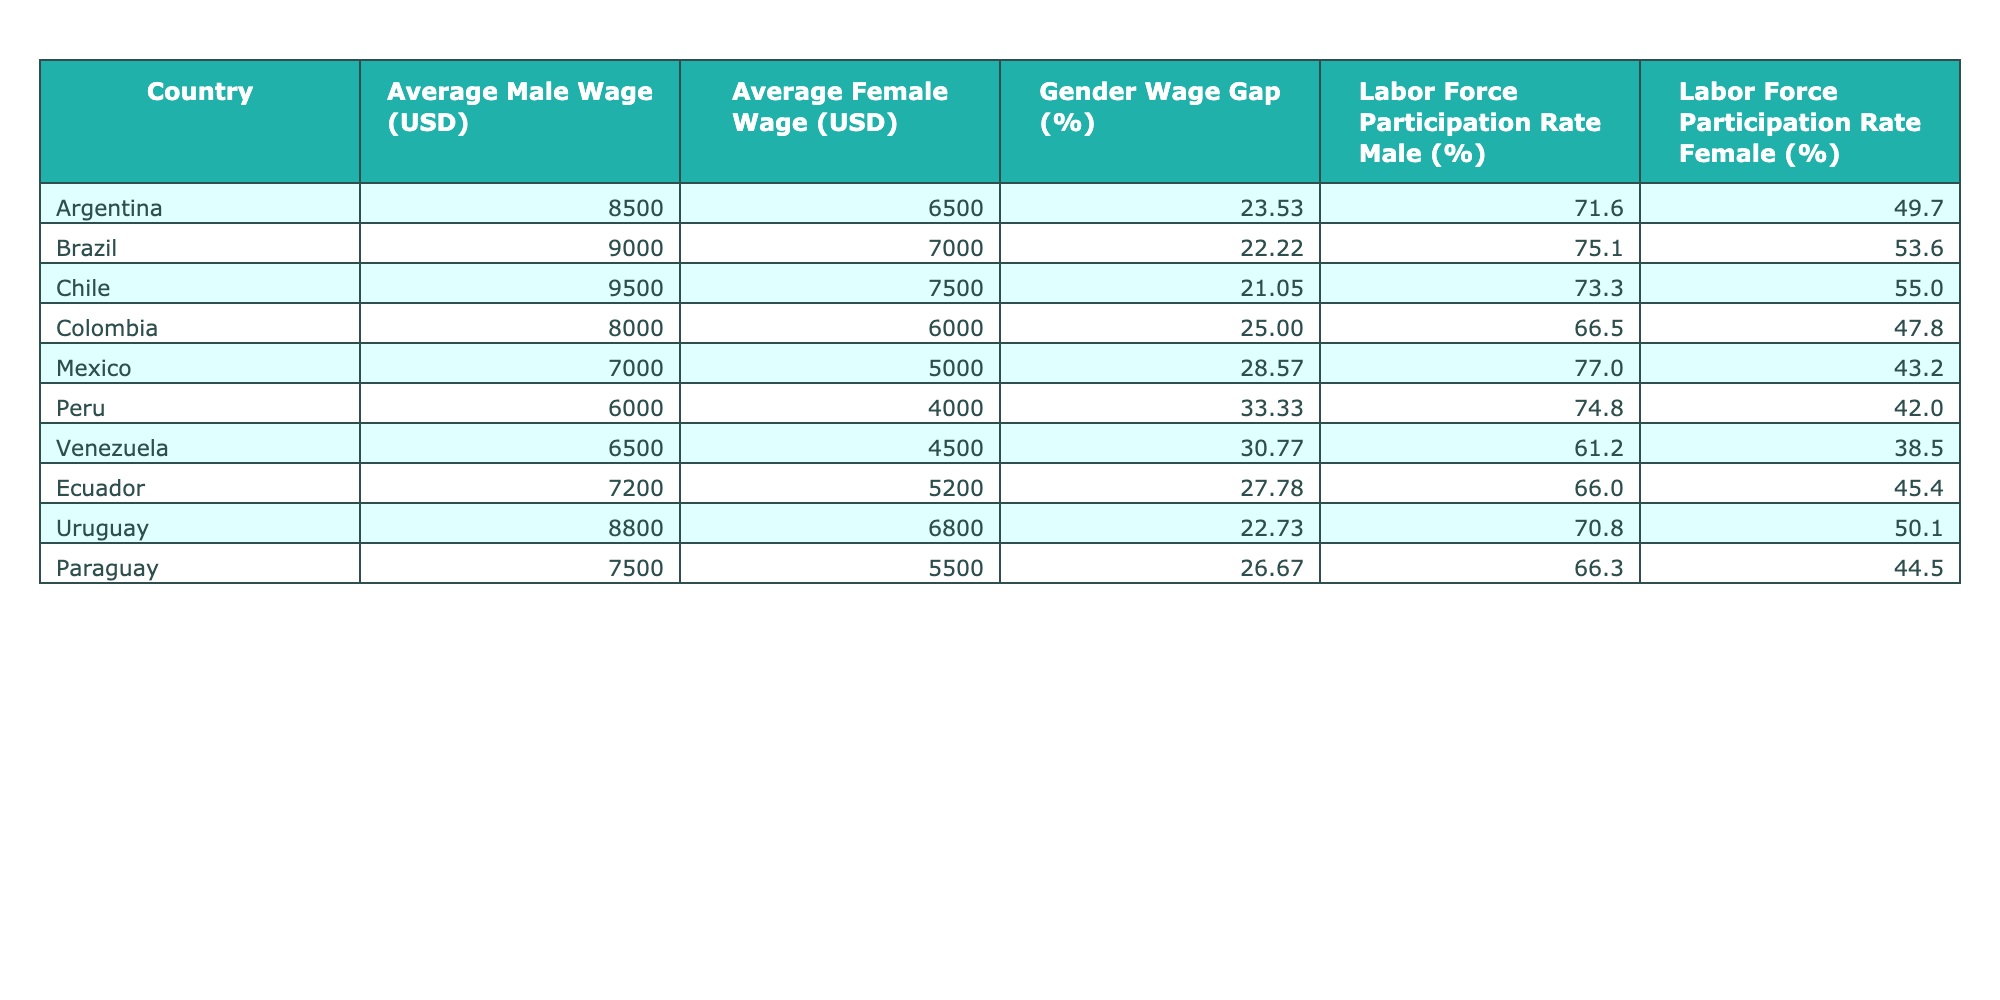What is the average male wage in Brazil? From the table, the specific value for the average male wage in Brazil is listed as 9000 USD.
Answer: 9000 USD Which country has the highest gender wage gap? By examining the table, the gender wage gap for Peru is 33.33%, which is the highest among the listed countries.
Answer: Peru What is the average female wage across all countries? The average female wage can be calculated by summing all the female wages (6500 + 7000 + 7500 + 6000 + 5000 + 4000 + 4500 + 5200 + 6800 + 5500) = 58800 USD and dividing by the number of countries (10), resulting in an average of 5880 USD.
Answer: 5880 USD Is the labor force participation rate for females in Argentina higher than that in Venezuela? The labor force participation rate for females in Argentina is 49.7%, and for Venezuela, it is 38.5%. Since 49.7% is greater than 38.5%, the statement is true.
Answer: Yes How much lower is the average male wage in Peru compared to the average female wage in Argentina? The average male wage in Peru is 6000 USD and the average female wage in Argentina is 6500 USD. The difference is 6500 - 6000 = 500 USD, indicating that the average male wage in Peru is 500 USD lower than the average female wage in Argentina.
Answer: 500 USD Which country has the closest average wages between genders? By reviewing the gender wage gaps, the smallest difference is in Chile with a gender wage gap of 21.05%, indicating that wages for males and females are closest in this country.
Answer: Chile What is the percentage difference in labor force participation rate between males and females in Colombia? In Colombia, males have a labor force participation rate of 66.5% and females have 47.8%. The percentage difference is calculated as (66.5 - 47.8) / 66.5 * 100 = 28.06%, showing the disparity in participation rates.
Answer: 28.06% Does any country have a gender wage gap of less than 22%? By checking the table, the countries with gender wage gaps are Argentine (23.53%), Brazil (22.22%), Chile (21.05%), and others. Since Chile has a gap of 21.05%, it's true that there is at least one country with a gender wage gap of less than 22%.
Answer: Yes What are the average male and female wages in Uruguay and how do they compare to each other? In Uruguay, the average male wage is 8800 USD and the average female wage is 6800 USD. The difference is 8800 - 6800 = 2000 USD, indicating that the male wage is 2000 USD higher than the female wage in Uruguay.
Answer: 2000 USD Which two countries have the highest average male and female wages, respectively? The highest average male wage is in Chile at 9500 USD, and the highest average female wage is also in Chile at 7500 USD. Thus, Chile holds the top position for both categories.
Answer: Chile How does the labor force participation rate for females in Peru compare to the overall average in the table? The average labor force participation rate for females across all the listed countries is (49.7 + 53.6 + 55.0 + 47.8 + 43.2 + 42.0 + 38.5 + 45.4 + 50.1 + 44.5) / 10 = 46.8%. Peru's female labor force participation rate is 42%, which is lower than the overall average of 46.8%.
Answer: Lower 